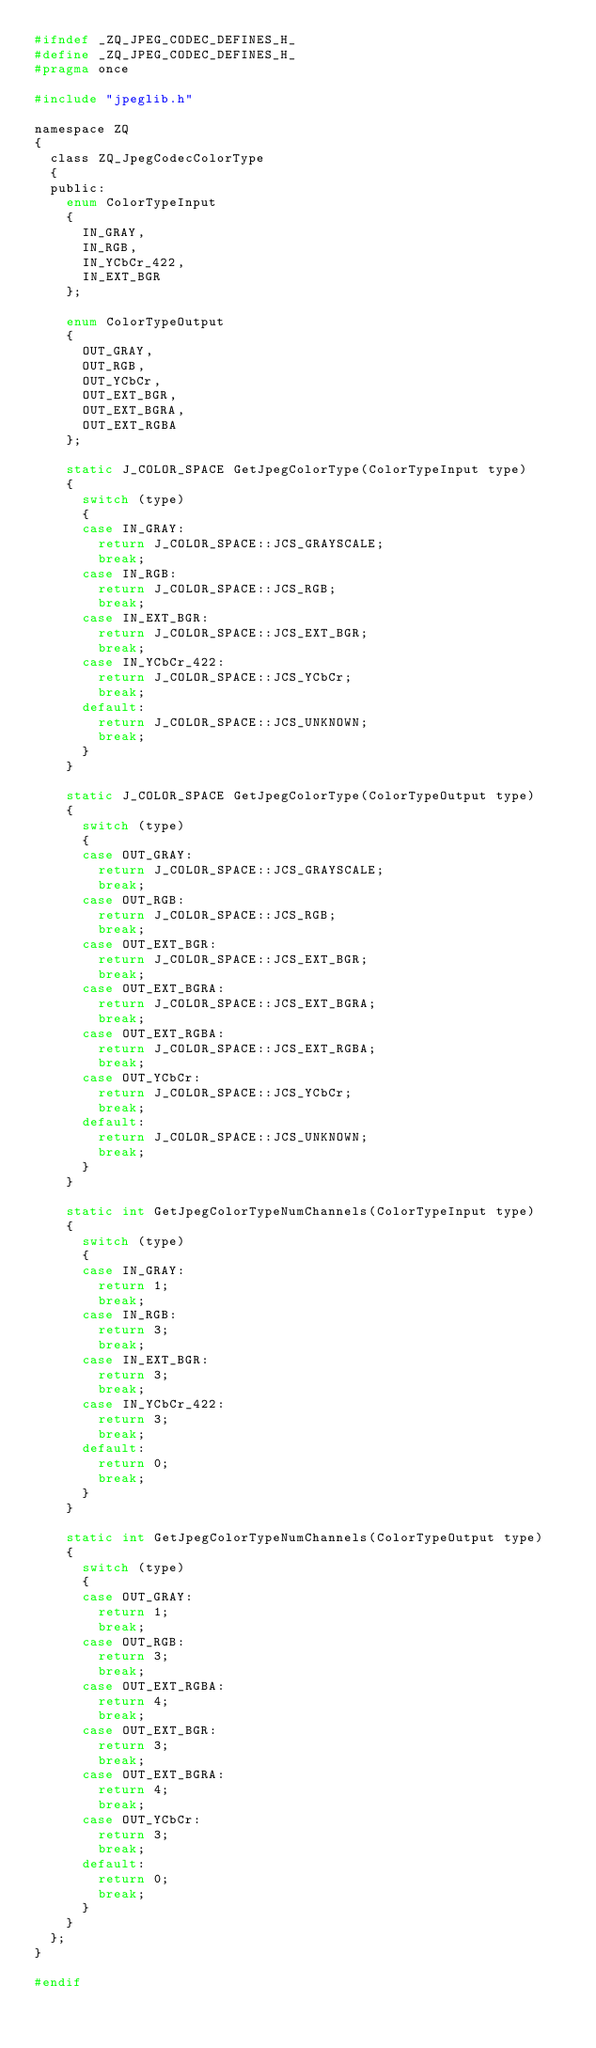Convert code to text. <code><loc_0><loc_0><loc_500><loc_500><_C_>#ifndef _ZQ_JPEG_CODEC_DEFINES_H_
#define _ZQ_JPEG_CODEC_DEFINES_H_
#pragma once

#include "jpeglib.h"

namespace ZQ
{
	class ZQ_JpegCodecColorType
	{
	public:
		enum ColorTypeInput
		{
			IN_GRAY,
			IN_RGB,
			IN_YCbCr_422,
			IN_EXT_BGR
		};

		enum ColorTypeOutput
		{
			OUT_GRAY,
			OUT_RGB,
			OUT_YCbCr,
			OUT_EXT_BGR,
			OUT_EXT_BGRA,
			OUT_EXT_RGBA
		};

		static J_COLOR_SPACE GetJpegColorType(ColorTypeInput type)
		{
			switch (type)
			{
			case IN_GRAY:
				return J_COLOR_SPACE::JCS_GRAYSCALE;
				break;
			case IN_RGB:
				return J_COLOR_SPACE::JCS_RGB;
				break;
			case IN_EXT_BGR:
				return J_COLOR_SPACE::JCS_EXT_BGR;
				break;
			case IN_YCbCr_422:
				return J_COLOR_SPACE::JCS_YCbCr;
				break;
			default:
				return J_COLOR_SPACE::JCS_UNKNOWN;
				break;
			}
		}

		static J_COLOR_SPACE GetJpegColorType(ColorTypeOutput type)
		{
			switch (type)
			{
			case OUT_GRAY:
				return J_COLOR_SPACE::JCS_GRAYSCALE;
				break;
			case OUT_RGB:
				return J_COLOR_SPACE::JCS_RGB;
				break;
			case OUT_EXT_BGR:
				return J_COLOR_SPACE::JCS_EXT_BGR;
				break;
			case OUT_EXT_BGRA:
				return J_COLOR_SPACE::JCS_EXT_BGRA;
				break;
			case OUT_EXT_RGBA:
				return J_COLOR_SPACE::JCS_EXT_RGBA;
				break;
			case OUT_YCbCr:
				return J_COLOR_SPACE::JCS_YCbCr;
				break;
			default:
				return J_COLOR_SPACE::JCS_UNKNOWN;
				break;
			}
		}

		static int GetJpegColorTypeNumChannels(ColorTypeInput type)
		{
			switch (type)
			{
			case IN_GRAY:
				return 1;
				break;
			case IN_RGB:
				return 3;
				break;
			case IN_EXT_BGR:
				return 3;
				break;
			case IN_YCbCr_422:
				return 3;
				break;
			default:
				return 0;
				break;
			}
		}

		static int GetJpegColorTypeNumChannels(ColorTypeOutput type)
		{
			switch (type)
			{
			case OUT_GRAY:
				return 1;
				break;
			case OUT_RGB:
				return 3;
				break;
			case OUT_EXT_RGBA:
				return 4;
				break;
			case OUT_EXT_BGR:
				return 3;
				break;
			case OUT_EXT_BGRA:
				return 4;
				break;
			case OUT_YCbCr:
				return 3;
				break;
			default:
				return 0;
				break;
			}
		}
	};
}

#endif</code> 